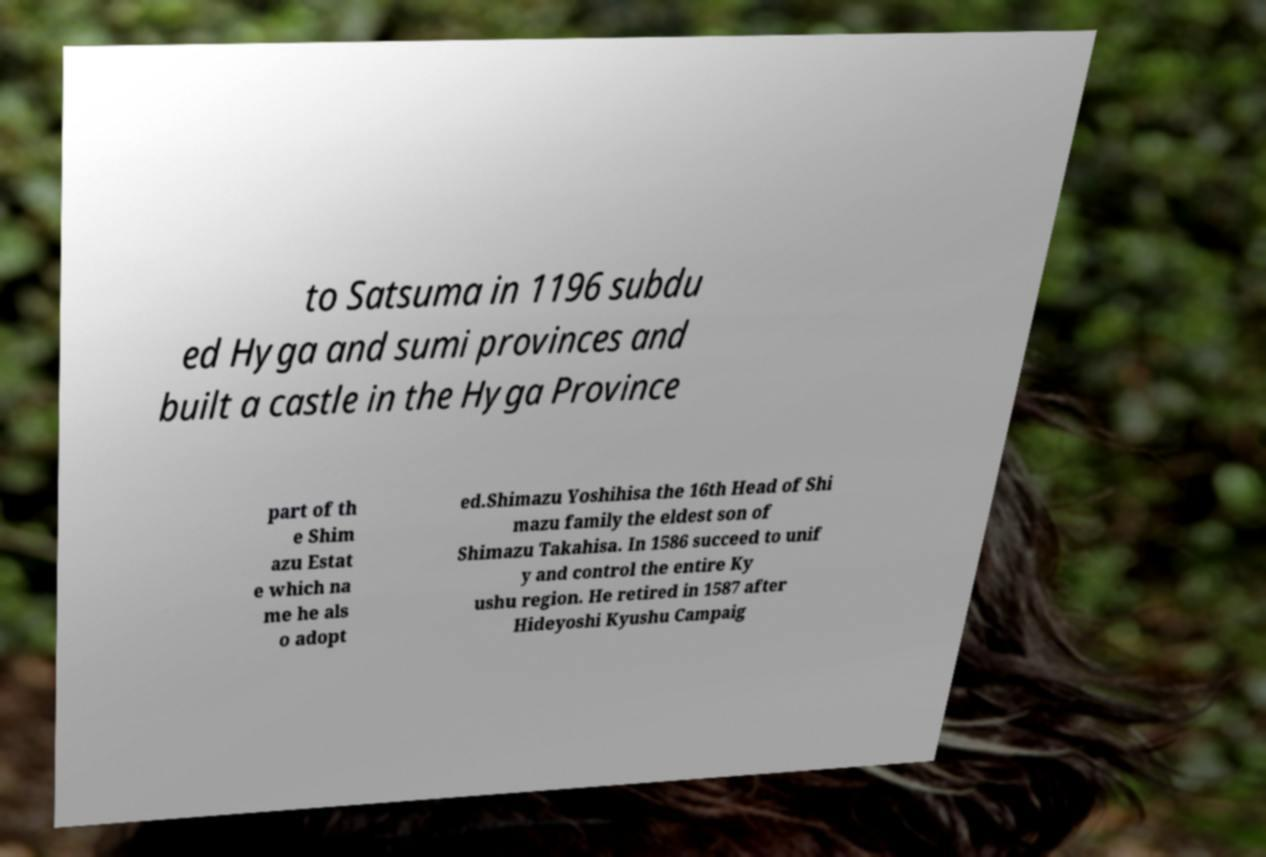There's text embedded in this image that I need extracted. Can you transcribe it verbatim? to Satsuma in 1196 subdu ed Hyga and sumi provinces and built a castle in the Hyga Province part of th e Shim azu Estat e which na me he als o adopt ed.Shimazu Yoshihisa the 16th Head of Shi mazu family the eldest son of Shimazu Takahisa. In 1586 succeed to unif y and control the entire Ky ushu region. He retired in 1587 after Hideyoshi Kyushu Campaig 